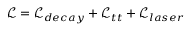Convert formula to latex. <formula><loc_0><loc_0><loc_500><loc_500>\mathcal { L } = \mathcal { L } _ { d e c a y } + \mathcal { L } _ { t t } + \mathcal { L } _ { l a s e r }</formula> 